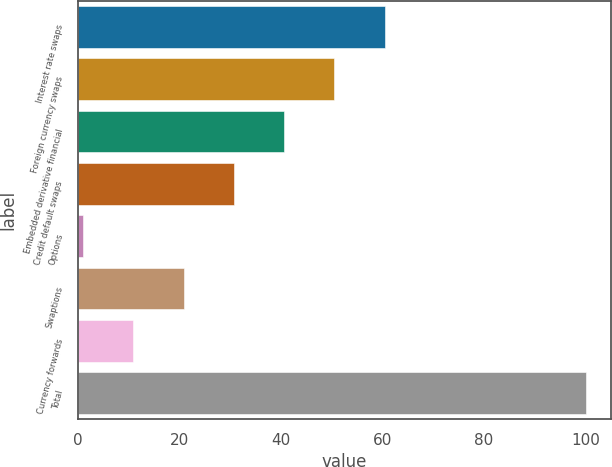Convert chart to OTSL. <chart><loc_0><loc_0><loc_500><loc_500><bar_chart><fcel>Interest rate swaps<fcel>Foreign currency swaps<fcel>Embedded derivative financial<fcel>Credit default swaps<fcel>Options<fcel>Swaptions<fcel>Currency forwards<fcel>Total<nl><fcel>60.4<fcel>50.5<fcel>40.6<fcel>30.7<fcel>1<fcel>20.8<fcel>10.9<fcel>100<nl></chart> 